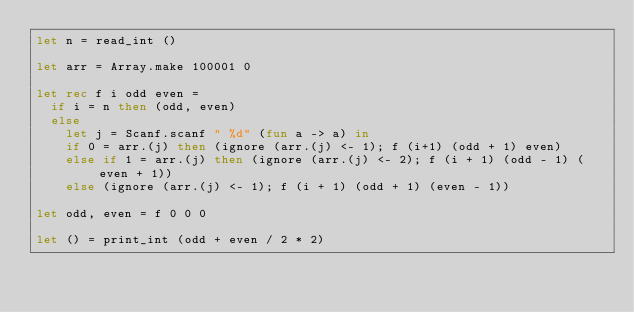Convert code to text. <code><loc_0><loc_0><loc_500><loc_500><_OCaml_>let n = read_int ()

let arr = Array.make 100001 0

let rec f i odd even =
  if i = n then (odd, even)
  else
    let j = Scanf.scanf " %d" (fun a -> a) in
    if 0 = arr.(j) then (ignore (arr.(j) <- 1); f (i+1) (odd + 1) even)
    else if 1 = arr.(j) then (ignore (arr.(j) <- 2); f (i + 1) (odd - 1) (even + 1))
    else (ignore (arr.(j) <- 1); f (i + 1) (odd + 1) (even - 1))
    
let odd, even = f 0 0 0

let () = print_int (odd + even / 2 * 2)</code> 